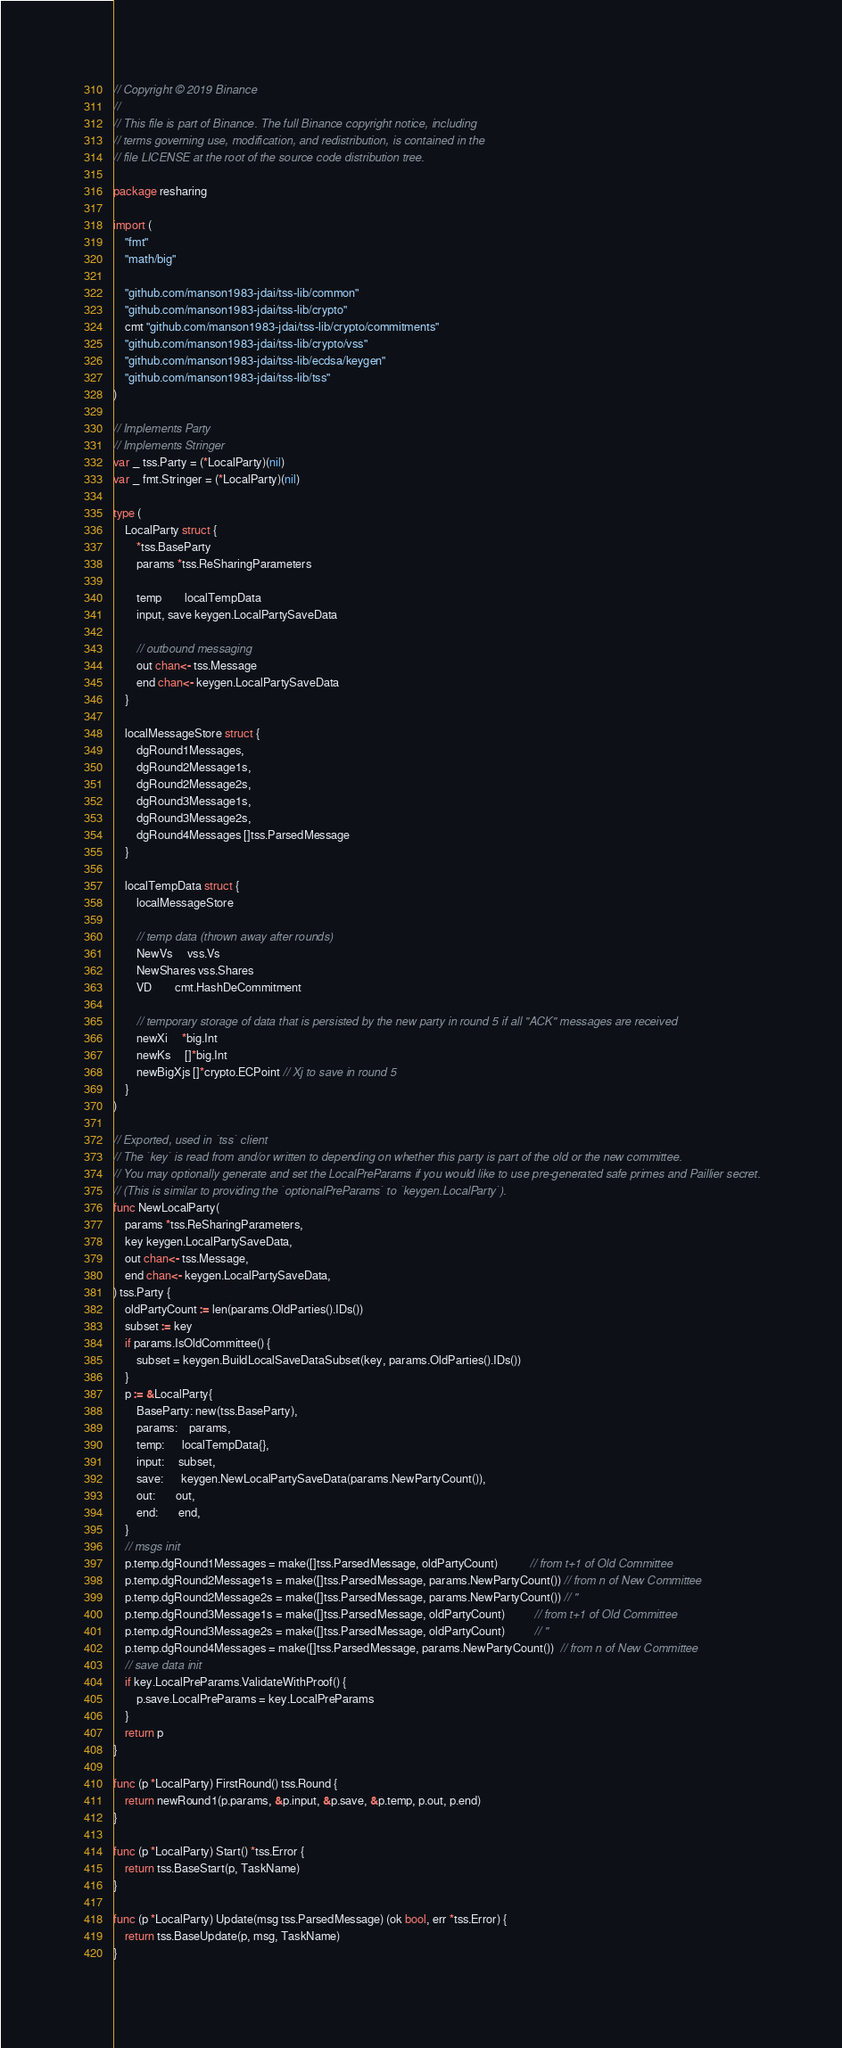Convert code to text. <code><loc_0><loc_0><loc_500><loc_500><_Go_>// Copyright © 2019 Binance
//
// This file is part of Binance. The full Binance copyright notice, including
// terms governing use, modification, and redistribution, is contained in the
// file LICENSE at the root of the source code distribution tree.

package resharing

import (
	"fmt"
	"math/big"

	"github.com/manson1983-jdai/tss-lib/common"
	"github.com/manson1983-jdai/tss-lib/crypto"
	cmt "github.com/manson1983-jdai/tss-lib/crypto/commitments"
	"github.com/manson1983-jdai/tss-lib/crypto/vss"
	"github.com/manson1983-jdai/tss-lib/ecdsa/keygen"
	"github.com/manson1983-jdai/tss-lib/tss"
)

// Implements Party
// Implements Stringer
var _ tss.Party = (*LocalParty)(nil)
var _ fmt.Stringer = (*LocalParty)(nil)

type (
	LocalParty struct {
		*tss.BaseParty
		params *tss.ReSharingParameters

		temp        localTempData
		input, save keygen.LocalPartySaveData

		// outbound messaging
		out chan<- tss.Message
		end chan<- keygen.LocalPartySaveData
	}

	localMessageStore struct {
		dgRound1Messages,
		dgRound2Message1s,
		dgRound2Message2s,
		dgRound3Message1s,
		dgRound3Message2s,
		dgRound4Messages []tss.ParsedMessage
	}

	localTempData struct {
		localMessageStore

		// temp data (thrown away after rounds)
		NewVs     vss.Vs
		NewShares vss.Shares
		VD        cmt.HashDeCommitment

		// temporary storage of data that is persisted by the new party in round 5 if all "ACK" messages are received
		newXi     *big.Int
		newKs     []*big.Int
		newBigXjs []*crypto.ECPoint // Xj to save in round 5
	}
)

// Exported, used in `tss` client
// The `key` is read from and/or written to depending on whether this party is part of the old or the new committee.
// You may optionally generate and set the LocalPreParams if you would like to use pre-generated safe primes and Paillier secret.
// (This is similar to providing the `optionalPreParams` to `keygen.LocalParty`).
func NewLocalParty(
	params *tss.ReSharingParameters,
	key keygen.LocalPartySaveData,
	out chan<- tss.Message,
	end chan<- keygen.LocalPartySaveData,
) tss.Party {
	oldPartyCount := len(params.OldParties().IDs())
	subset := key
	if params.IsOldCommittee() {
		subset = keygen.BuildLocalSaveDataSubset(key, params.OldParties().IDs())
	}
	p := &LocalParty{
		BaseParty: new(tss.BaseParty),
		params:    params,
		temp:      localTempData{},
		input:     subset,
		save:      keygen.NewLocalPartySaveData(params.NewPartyCount()),
		out:       out,
		end:       end,
	}
	// msgs init
	p.temp.dgRound1Messages = make([]tss.ParsedMessage, oldPartyCount)           // from t+1 of Old Committee
	p.temp.dgRound2Message1s = make([]tss.ParsedMessage, params.NewPartyCount()) // from n of New Committee
	p.temp.dgRound2Message2s = make([]tss.ParsedMessage, params.NewPartyCount()) // "
	p.temp.dgRound3Message1s = make([]tss.ParsedMessage, oldPartyCount)          // from t+1 of Old Committee
	p.temp.dgRound3Message2s = make([]tss.ParsedMessage, oldPartyCount)          // "
	p.temp.dgRound4Messages = make([]tss.ParsedMessage, params.NewPartyCount())  // from n of New Committee
	// save data init
	if key.LocalPreParams.ValidateWithProof() {
		p.save.LocalPreParams = key.LocalPreParams
	}
	return p
}

func (p *LocalParty) FirstRound() tss.Round {
	return newRound1(p.params, &p.input, &p.save, &p.temp, p.out, p.end)
}

func (p *LocalParty) Start() *tss.Error {
	return tss.BaseStart(p, TaskName)
}

func (p *LocalParty) Update(msg tss.ParsedMessage) (ok bool, err *tss.Error) {
	return tss.BaseUpdate(p, msg, TaskName)
}
</code> 